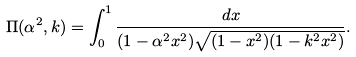Convert formula to latex. <formula><loc_0><loc_0><loc_500><loc_500>\Pi ( \alpha ^ { 2 } , k ) = \int _ { 0 } ^ { 1 } \frac { d x } { ( 1 - \alpha ^ { 2 } x ^ { 2 } ) \sqrt { ( 1 - x ^ { 2 } ) ( 1 - k ^ { 2 } x ^ { 2 } ) } } .</formula> 